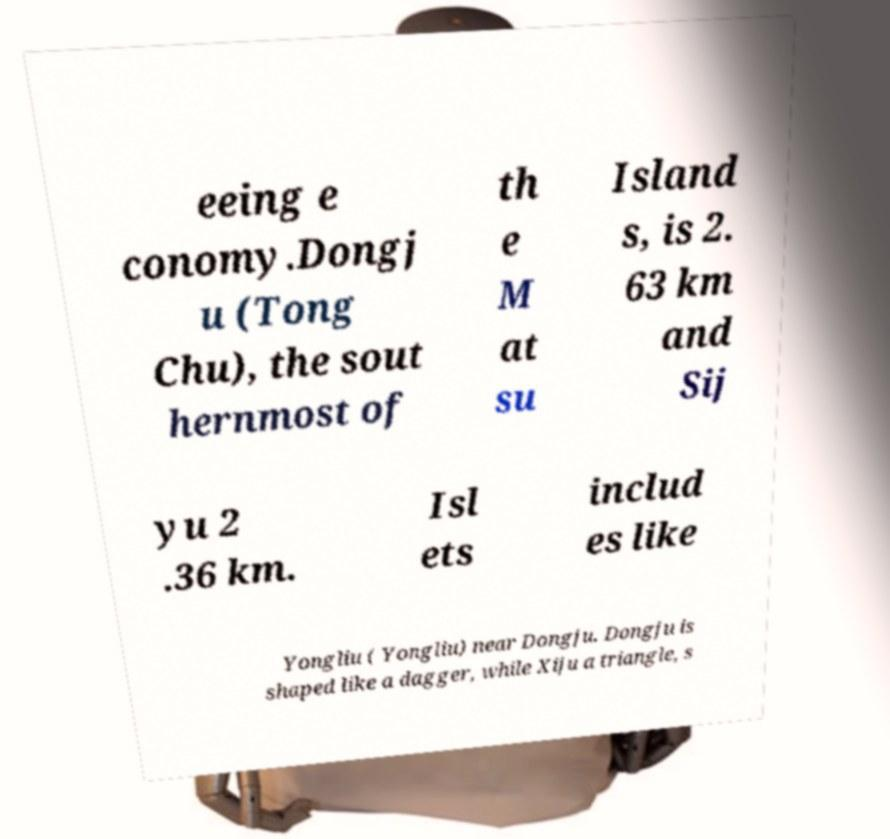Can you accurately transcribe the text from the provided image for me? eeing e conomy.Dongj u (Tong Chu), the sout hernmost of th e M at su Island s, is 2. 63 km and Sij yu 2 .36 km. Isl ets includ es like Yongliu ( Yongliu) near Dongju. Dongju is shaped like a dagger, while Xiju a triangle, s 